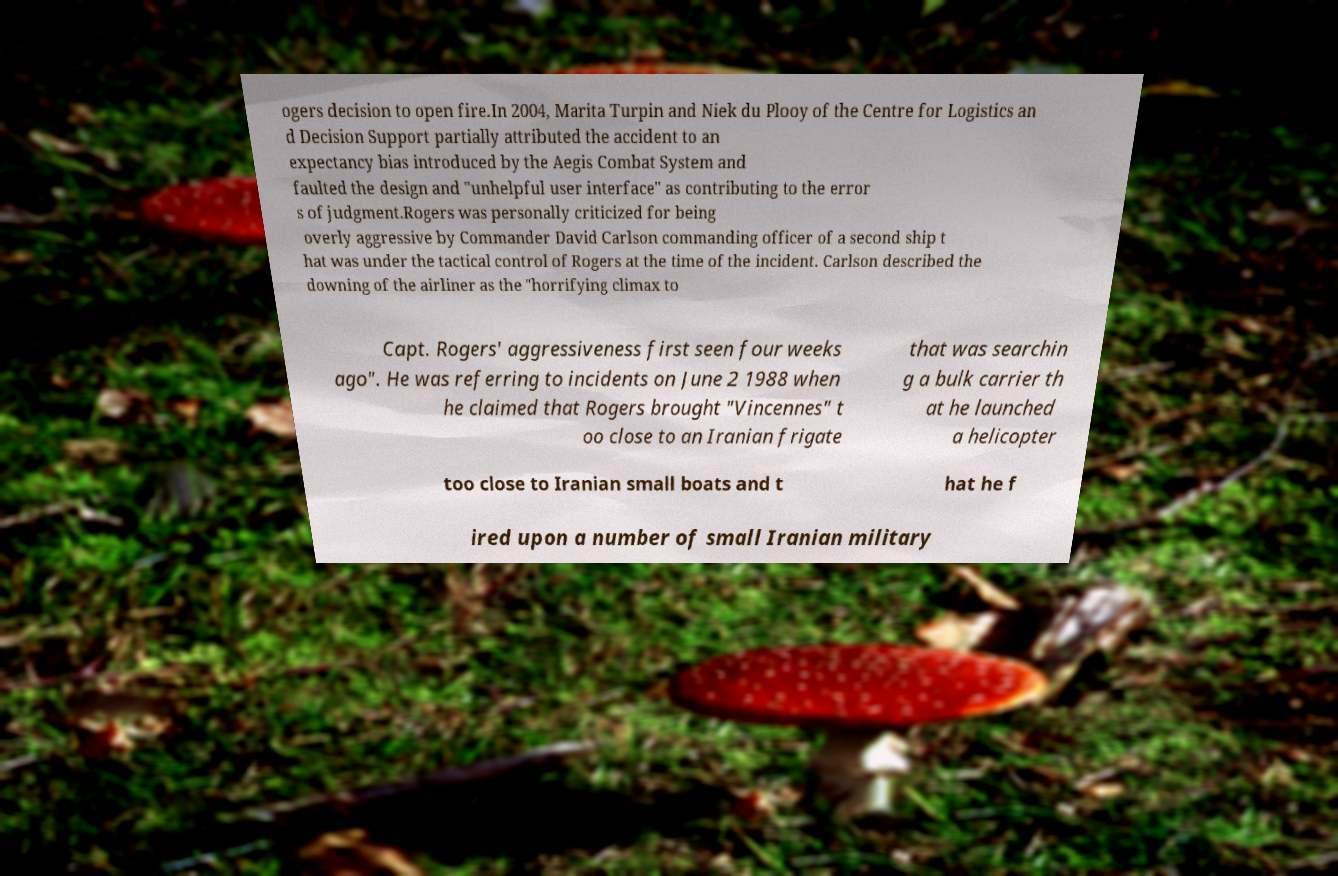What messages or text are displayed in this image? I need them in a readable, typed format. ogers decision to open fire.In 2004, Marita Turpin and Niek du Plooy of the Centre for Logistics an d Decision Support partially attributed the accident to an expectancy bias introduced by the Aegis Combat System and faulted the design and "unhelpful user interface" as contributing to the error s of judgment.Rogers was personally criticized for being overly aggressive by Commander David Carlson commanding officer of a second ship t hat was under the tactical control of Rogers at the time of the incident. Carlson described the downing of the airliner as the "horrifying climax to Capt. Rogers' aggressiveness first seen four weeks ago". He was referring to incidents on June 2 1988 when he claimed that Rogers brought "Vincennes" t oo close to an Iranian frigate that was searchin g a bulk carrier th at he launched a helicopter too close to Iranian small boats and t hat he f ired upon a number of small Iranian military 